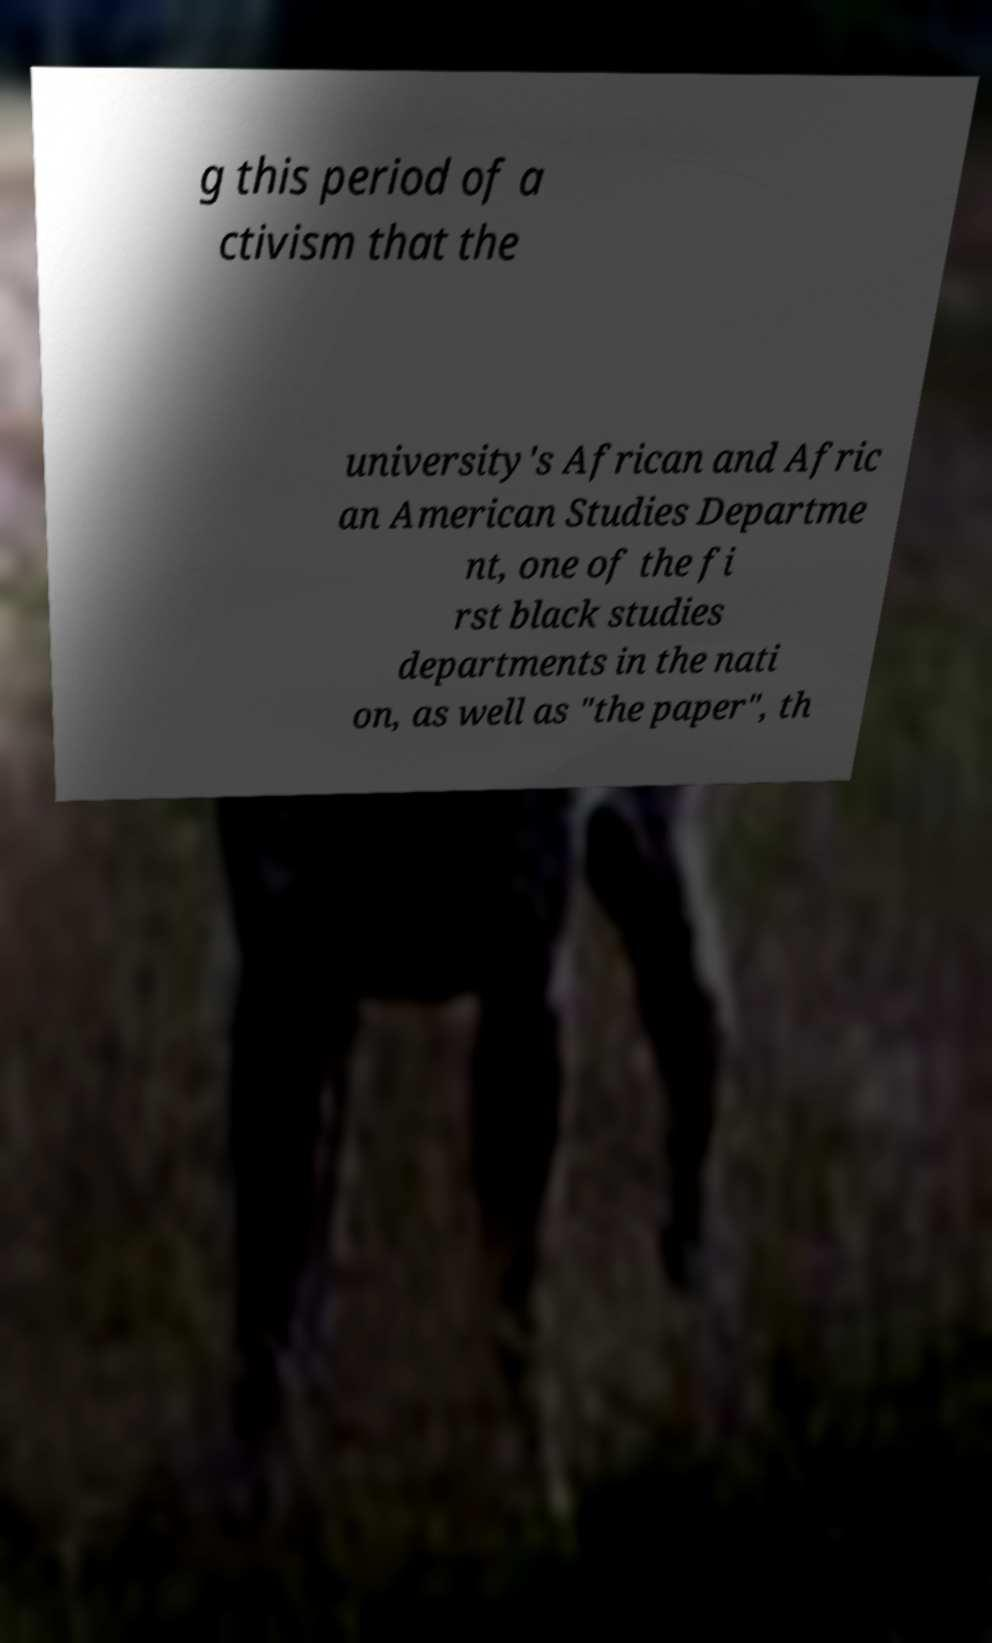Can you accurately transcribe the text from the provided image for me? g this period of a ctivism that the university's African and Afric an American Studies Departme nt, one of the fi rst black studies departments in the nati on, as well as "the paper", th 